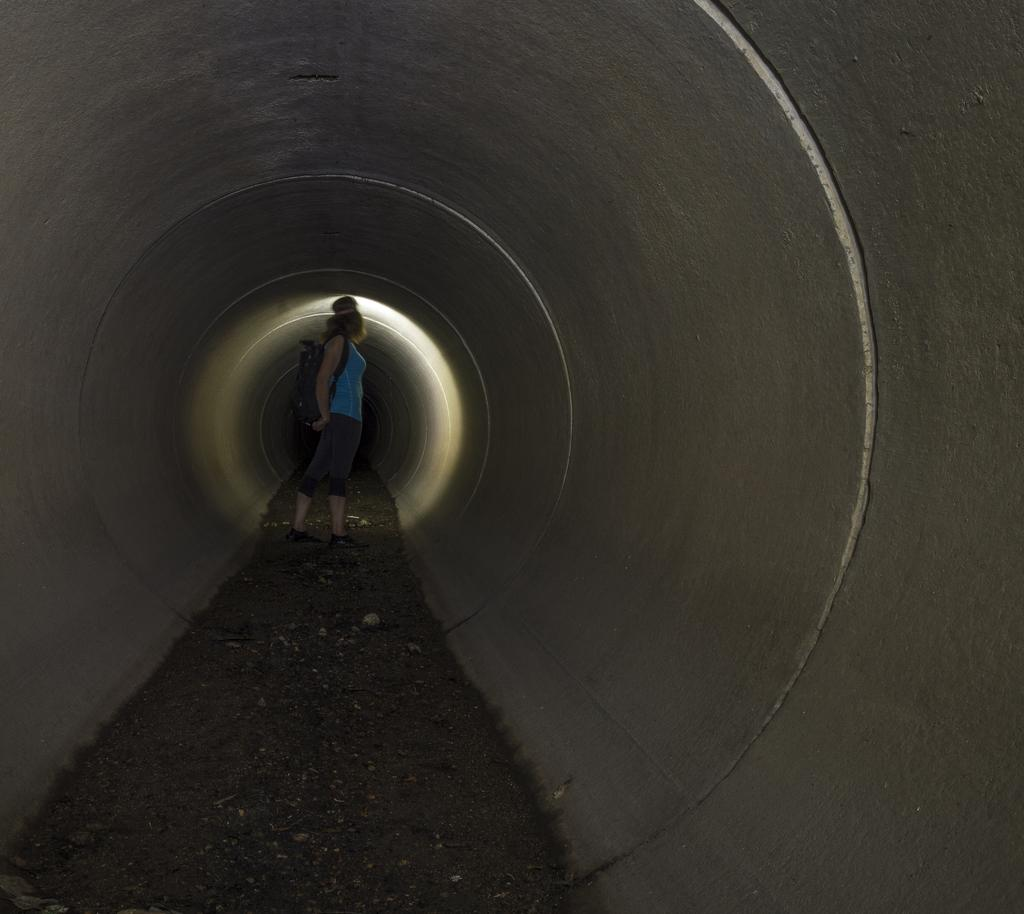Who is present in the image? There is a lady in the image. What is the lady wearing? The lady is wearing a bag. Where does the scene take place? The scene takes place in a tunnel. What type of gold can be seen in the lady's bag in the image? There is no gold visible in the image, and the lady's bag is not described as containing any gold. 